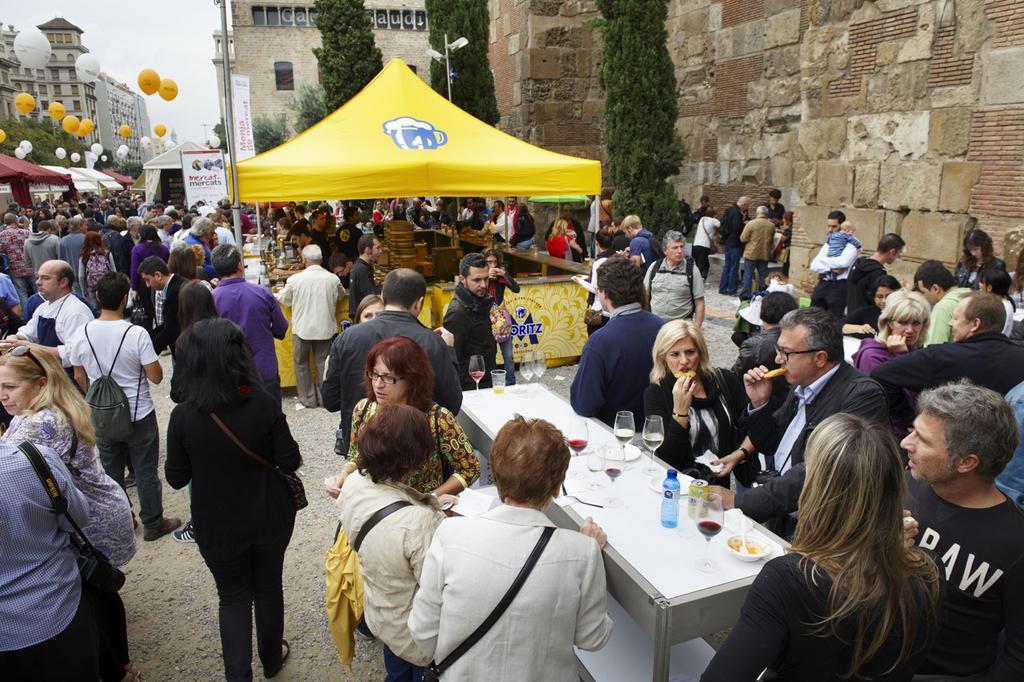Describe this image in one or two sentences. In this image, we can see tents, balloons, tables, glasses, bottles and there are many people. In the background, there are buildings, poles, trees, banners. 